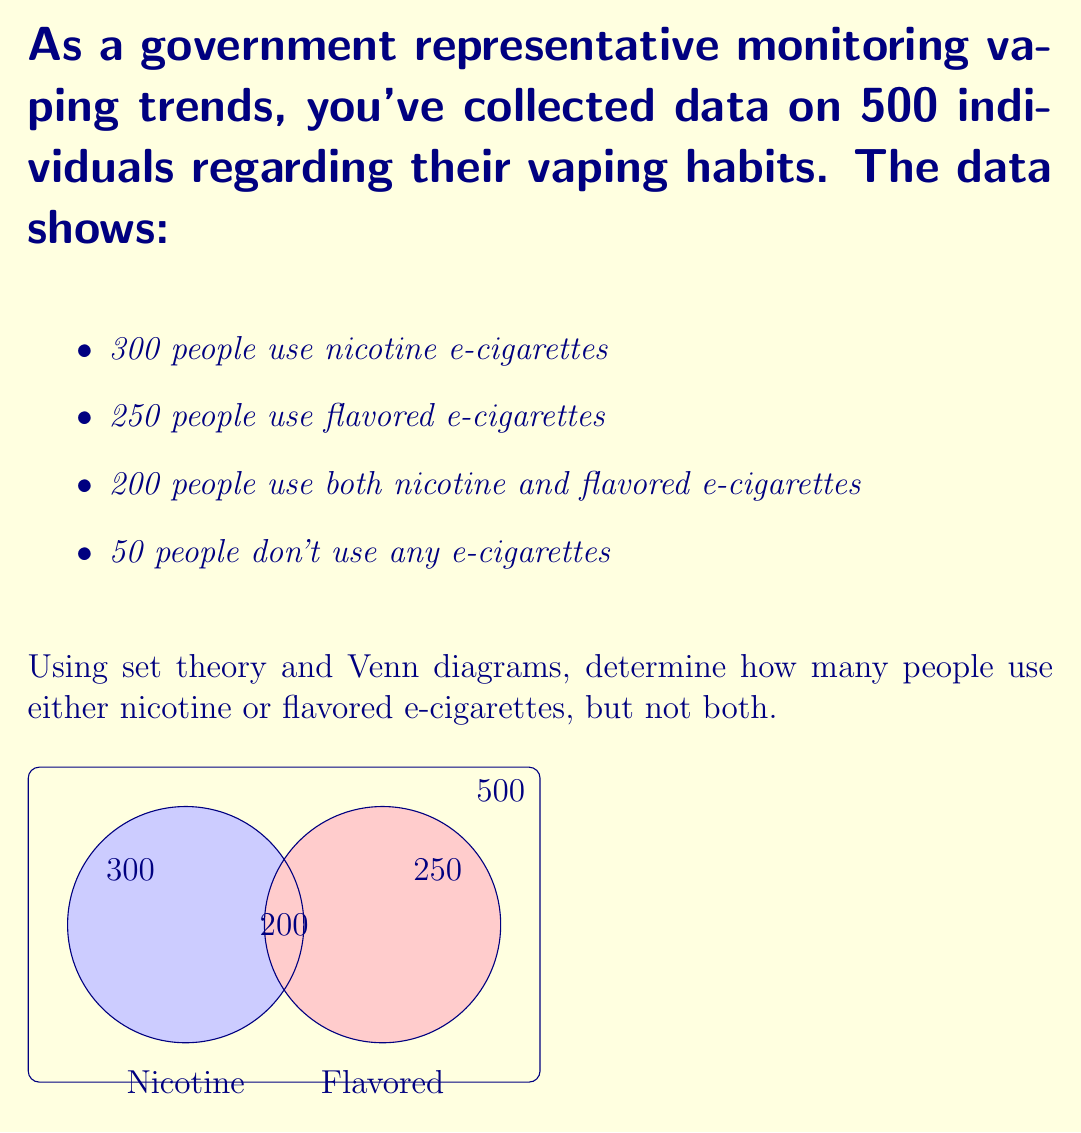Can you answer this question? Let's approach this step-by-step using set theory and the given Venn diagram:

1) Let N be the set of people who use nicotine e-cigarettes and F be the set of people who use flavored e-cigarettes.

2) We're given:
   $|N| = 300$
   $|F| = 250$
   $|N \cap F| = 200$
   Number of people who don't use any e-cigarettes = 50

3) We need to find $|N \cup F| - |N \cap F|$, which represents people who use either nicotine or flavored e-cigarettes, but not both.

4) First, let's find $|N \cup F|$ using the inclusion-exclusion principle:
   $|N \cup F| = |N| + |F| - |N \cap F|$
   $|N \cup F| = 300 + 250 - 200 = 350$

5) This means 350 people use either nicotine or flavored e-cigarettes (or both).

6) To find those who use either but not both, we subtract $|N \cap F|$ from $|N \cup F|$:
   $|N \cup F| - |N \cap F| = 350 - 200 = 150$

7) We can verify this result:
   Total population = 500
   People using both types = 200
   People using neither type = 50
   People using either but not both = 500 - 200 - 50 = 250

8) The difference between our calculated value and the verification (150 vs 250) is 100, which represents people using only one type of e-cigarette.
Answer: 150 people 